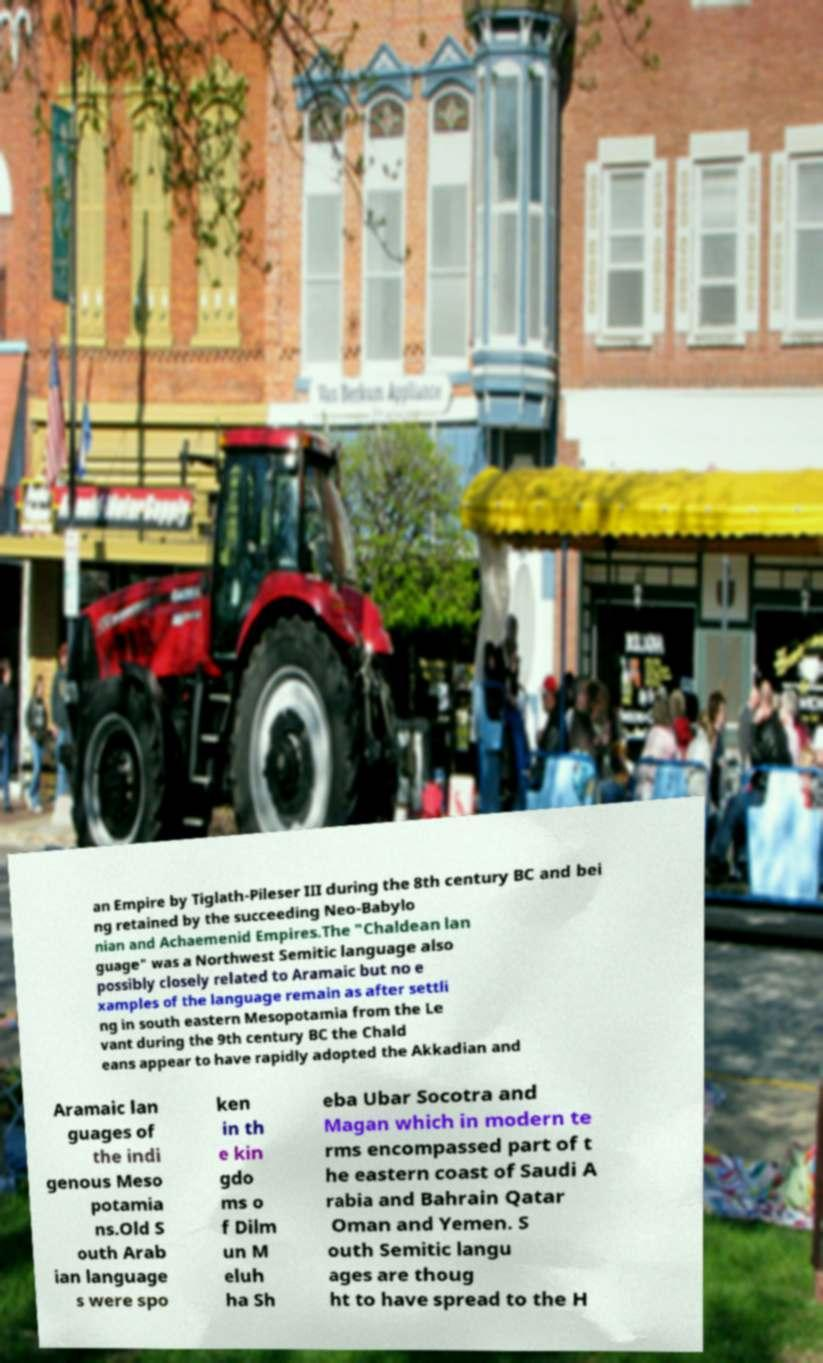Please read and relay the text visible in this image. What does it say? an Empire by Tiglath-Pileser III during the 8th century BC and bei ng retained by the succeeding Neo-Babylo nian and Achaemenid Empires.The "Chaldean lan guage" was a Northwest Semitic language also possibly closely related to Aramaic but no e xamples of the language remain as after settli ng in south eastern Mesopotamia from the Le vant during the 9th century BC the Chald eans appear to have rapidly adopted the Akkadian and Aramaic lan guages of the indi genous Meso potamia ns.Old S outh Arab ian language s were spo ken in th e kin gdo ms o f Dilm un M eluh ha Sh eba Ubar Socotra and Magan which in modern te rms encompassed part of t he eastern coast of Saudi A rabia and Bahrain Qatar Oman and Yemen. S outh Semitic langu ages are thoug ht to have spread to the H 